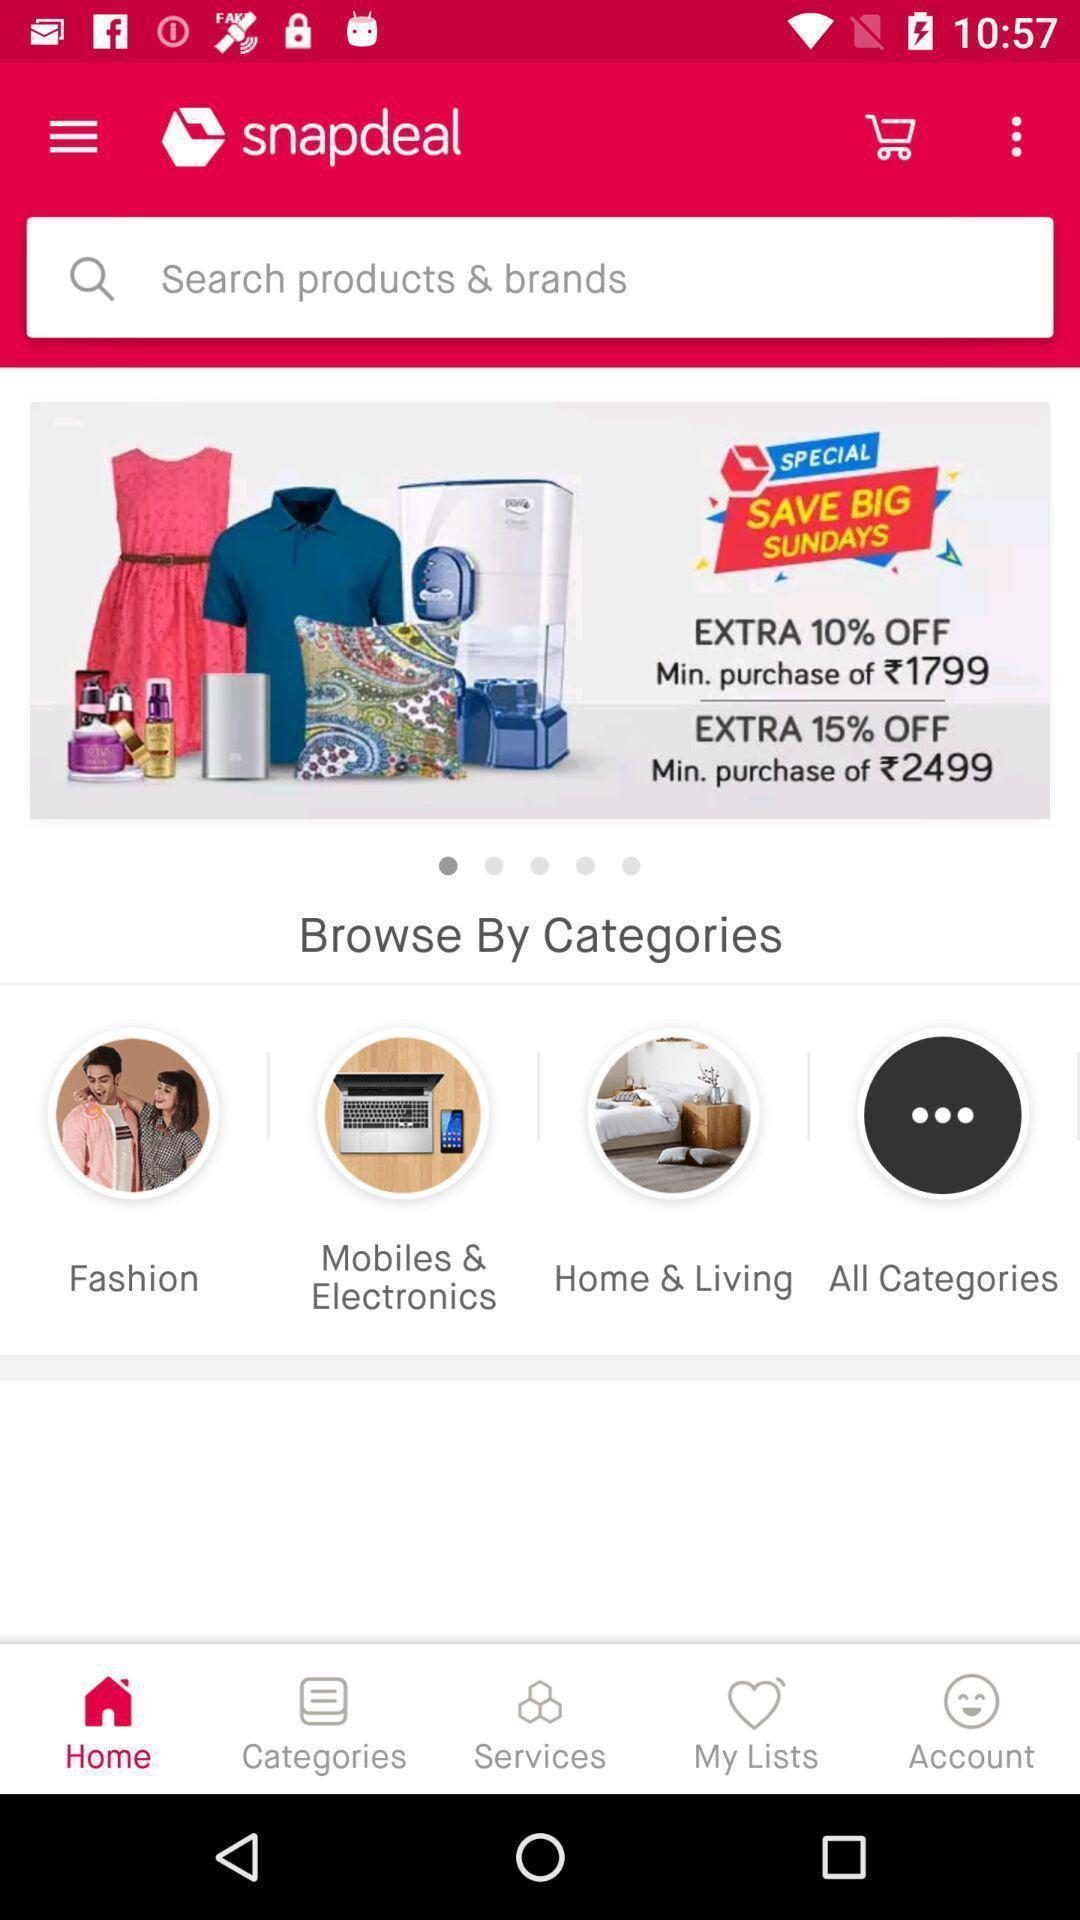Summarize the main components in this picture. Screen displaying of an shopping application. 